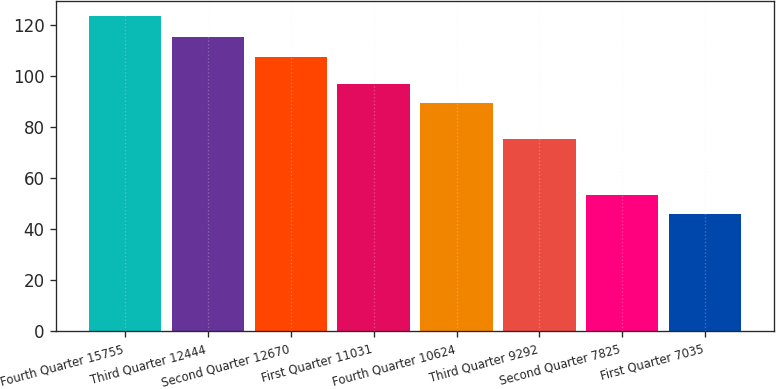<chart> <loc_0><loc_0><loc_500><loc_500><bar_chart><fcel>Fourth Quarter 15755<fcel>Third Quarter 12444<fcel>Second Quarter 12670<fcel>First Quarter 11031<fcel>Fourth Quarter 10624<fcel>Third Quarter 9292<fcel>Second Quarter 7825<fcel>First Quarter 7035<nl><fcel>123.28<fcel>115.18<fcel>107.42<fcel>96.96<fcel>89.2<fcel>75.33<fcel>53.48<fcel>45.72<nl></chart> 